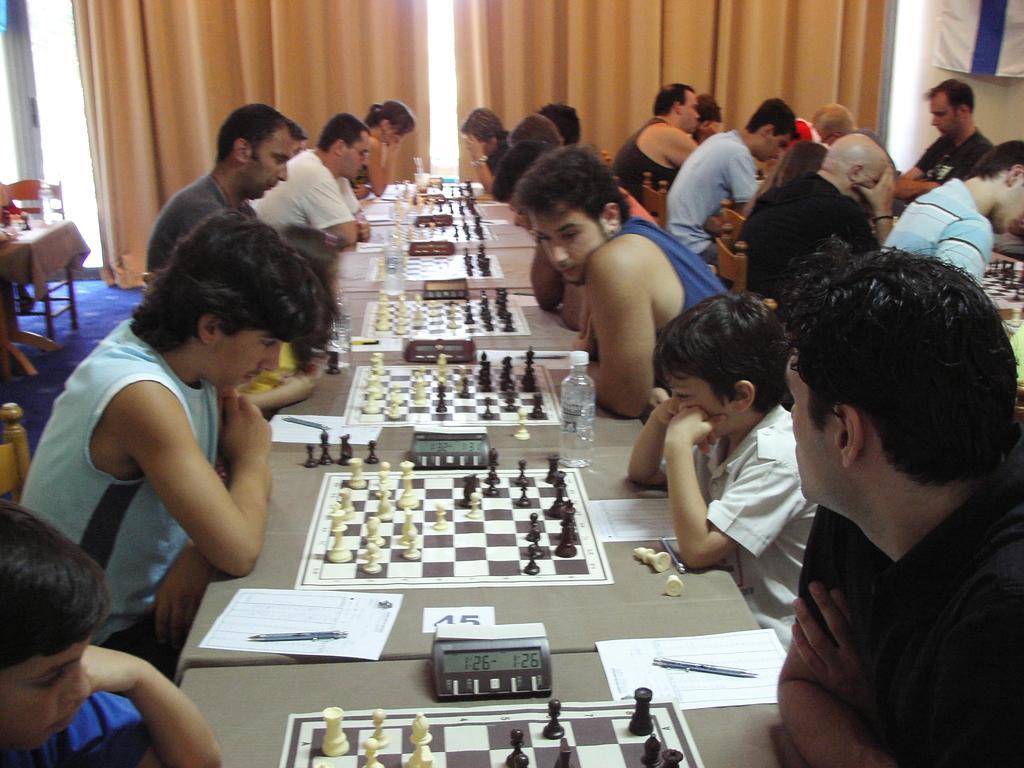Describe this image in one or two sentences. In this picture we can see some persons sitting on the chairs. This is table. On the table there are chess boards, paper, pen, and a bottle. On the background there is a curtain. This is the floor. 